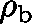<formula> <loc_0><loc_0><loc_500><loc_500>\rho _ { b }</formula> 